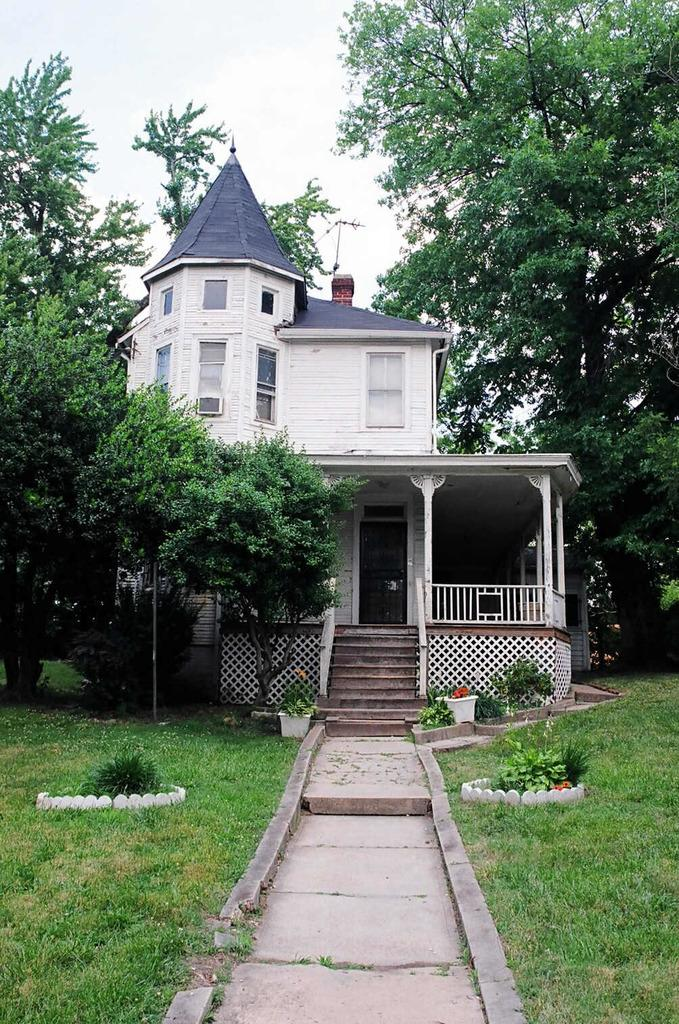What type of structure is present in the picture? There is a house in the picture. What type of vegetation can be seen in the picture? There are trees in the picture. What type of ground cover is present in the picture? There is grass in the picture. Is there any indication of a path or walkway in the picture? Yes, there is a path in the picture. How many pigs are visible in the picture? There are no pigs present in the picture. What type of fuel is being used by the house in the picture? The picture does not provide any information about the type of fuel used by the house. 